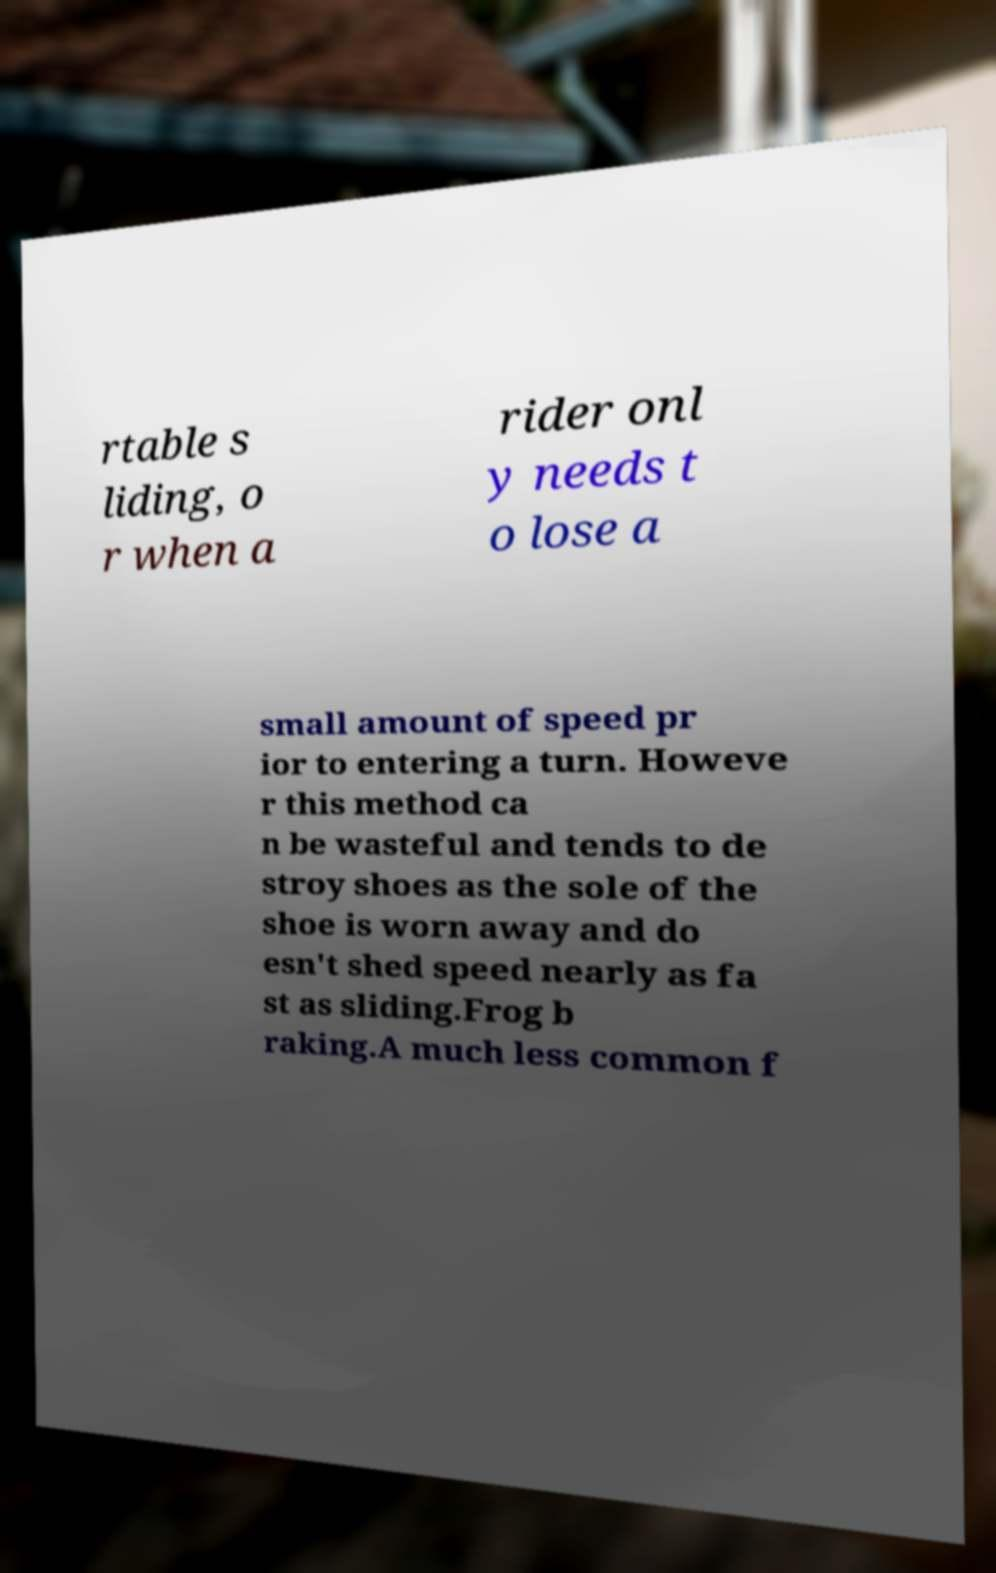Please read and relay the text visible in this image. What does it say? rtable s liding, o r when a rider onl y needs t o lose a small amount of speed pr ior to entering a turn. Howeve r this method ca n be wasteful and tends to de stroy shoes as the sole of the shoe is worn away and do esn't shed speed nearly as fa st as sliding.Frog b raking.A much less common f 